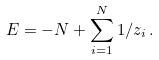<formula> <loc_0><loc_0><loc_500><loc_500>E = - N + \sum _ { i = 1 } ^ { N } 1 / z _ { i } \, .</formula> 